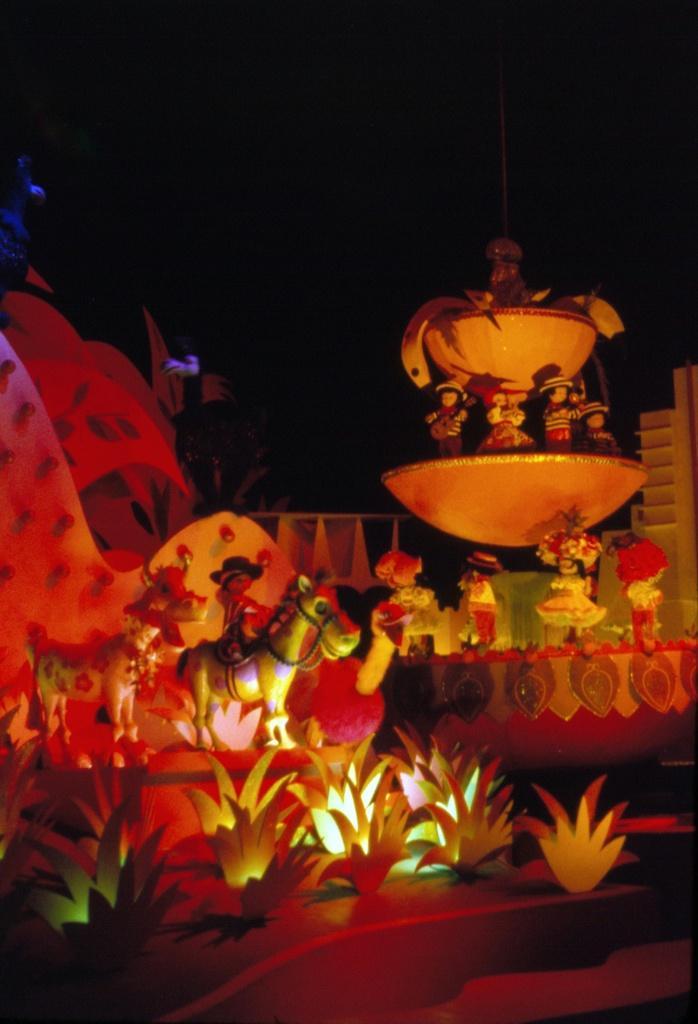In one or two sentences, can you explain what this image depicts? On the right side of the image we can see fountain. On the left side of the image we can see toys. In the background there is sky. 